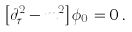<formula> <loc_0><loc_0><loc_500><loc_500>\left [ \partial ^ { 2 } _ { \tau } - m ^ { 2 } \right ] \phi _ { 0 } = 0 \, .</formula> 